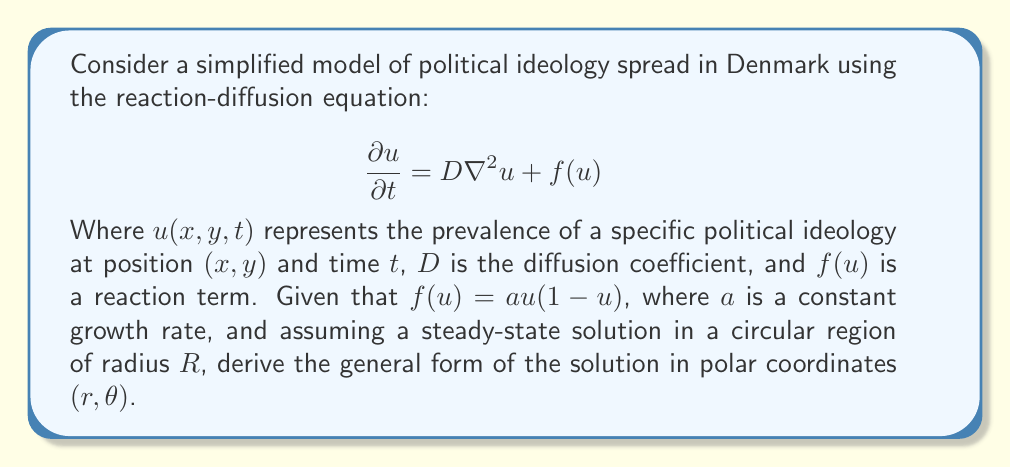Can you solve this math problem? 1. In steady-state, the time derivative is zero: $\frac{\partial u}{\partial t} = 0$

2. The Laplacian in polar coordinates is:
   $$\nabla^2u = \frac{1}{r}\frac{\partial}{\partial r}\left(r\frac{\partial u}{\partial r}\right) + \frac{1}{r^2}\frac{\partial^2 u}{\partial \theta^2}$$

3. Substituting into the original equation:
   $$0 = D\left[\frac{1}{r}\frac{\partial}{\partial r}\left(r\frac{\partial u}{\partial r}\right) + \frac{1}{r^2}\frac{\partial^2 u}{\partial \theta^2}\right] + au(1-u)$$

4. Assuming radial symmetry (no dependence on $\theta$), we get:
   $$0 = \frac{D}{r}\frac{d}{dr}\left(r\frac{du}{dr}\right) + au(1-u)$$

5. Let $v = \frac{du}{dr}$. Then $\frac{dv}{dr} = \frac{d^2u}{dr^2}$

6. Rewriting the equation:
   $$r\frac{dv}{dr} + v + \frac{ar}{D}u(1-u) = 0$$

7. This is a non-linear equation. To find a general form, we can look for solutions of the type:
   $$u(r) = \frac{1}{1 + Ae^{\alpha r}}$$

   Where $A$ and $\alpha$ are constants to be determined.

8. Differentiating:
   $$\frac{du}{dr} = -\frac{\alpha Ae^{\alpha r}}{(1 + Ae^{\alpha r})^2}$$

9. Substituting back into the original equation and simplifying, we find that this is a solution if:
   $$\alpha^2 = \frac{a}{2D}$$

10. Therefore, the general form of the solution is:
    $$u(r) = \frac{1}{1 + Ae^{\sqrt{\frac{a}{2D}}r}}$$

    Where $A$ is determined by boundary conditions.
Answer: $u(r) = \frac{1}{1 + Ae^{\sqrt{\frac{a}{2D}}r}}$ 